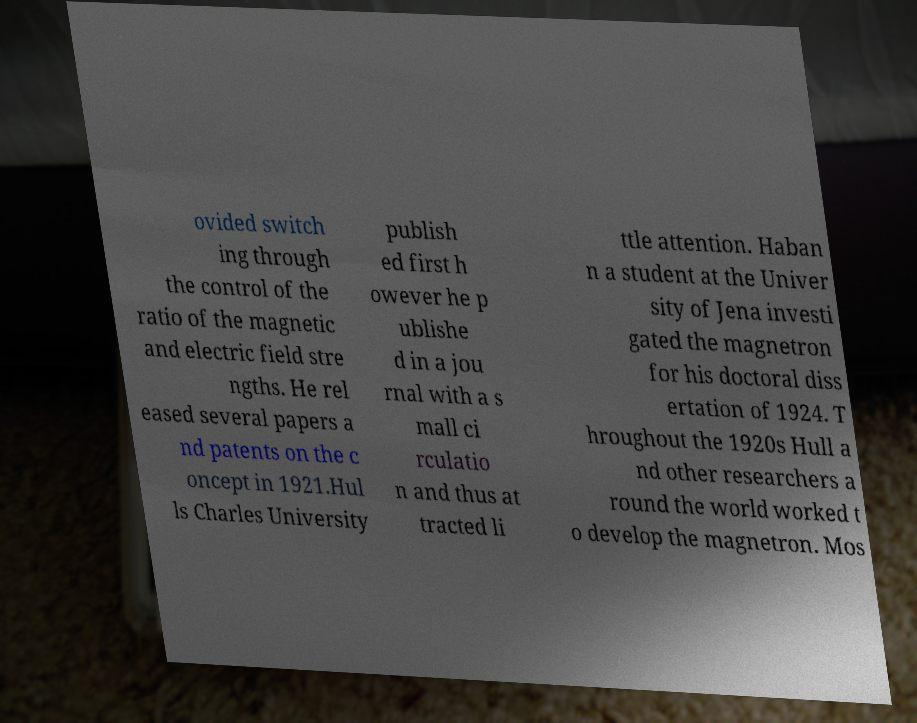For documentation purposes, I need the text within this image transcribed. Could you provide that? ovided switch ing through the control of the ratio of the magnetic and electric field stre ngths. He rel eased several papers a nd patents on the c oncept in 1921.Hul ls Charles University publish ed first h owever he p ublishe d in a jou rnal with a s mall ci rculatio n and thus at tracted li ttle attention. Haban n a student at the Univer sity of Jena investi gated the magnetron for his doctoral diss ertation of 1924. T hroughout the 1920s Hull a nd other researchers a round the world worked t o develop the magnetron. Mos 